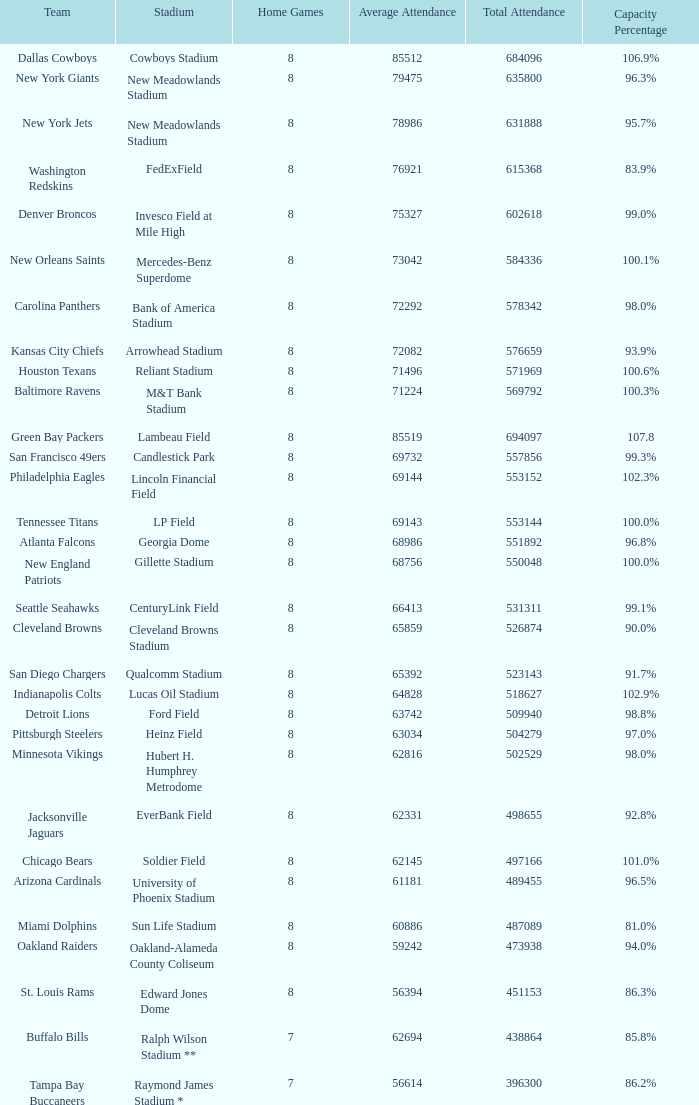What is the name of the team when the stadium is listed as Edward Jones Dome? St. Louis Rams. 